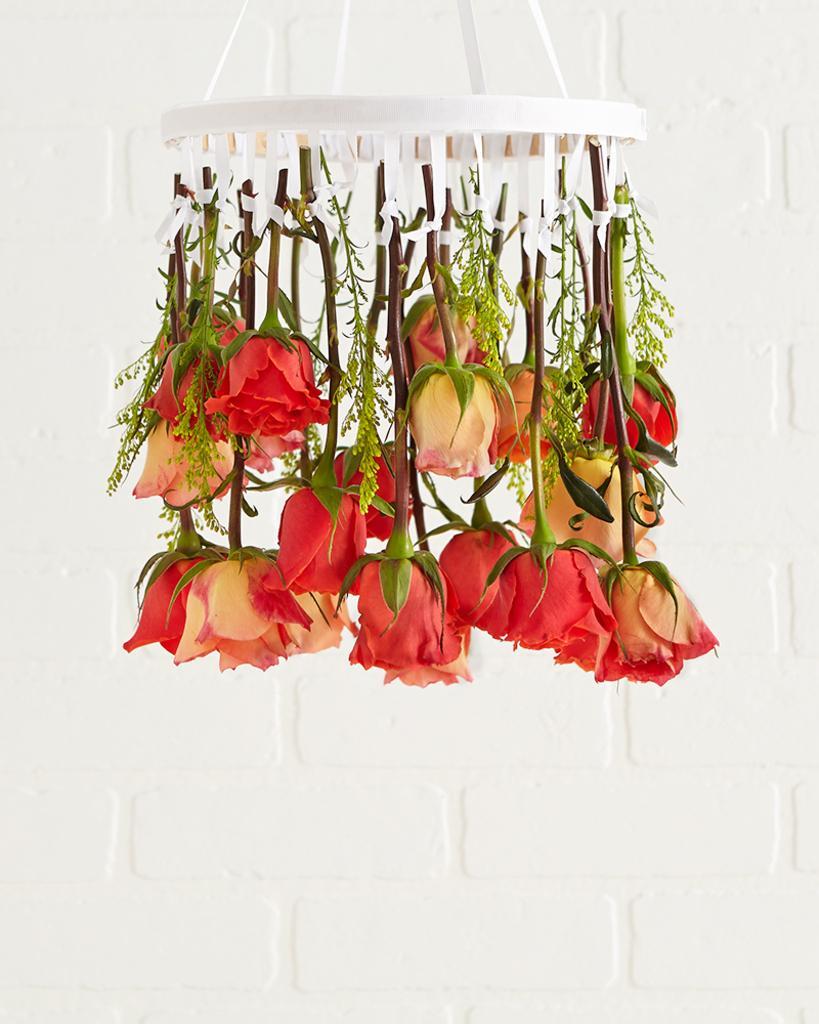Please provide a concise description of this image. In this image I can see few flowers hanging to the white color object and the flowers are in red and cream color and I can see the white color background. 